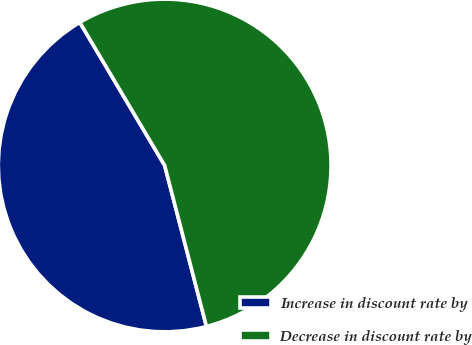Convert chart. <chart><loc_0><loc_0><loc_500><loc_500><pie_chart><fcel>Increase in discount rate by<fcel>Decrease in discount rate by<nl><fcel>45.52%<fcel>54.48%<nl></chart> 